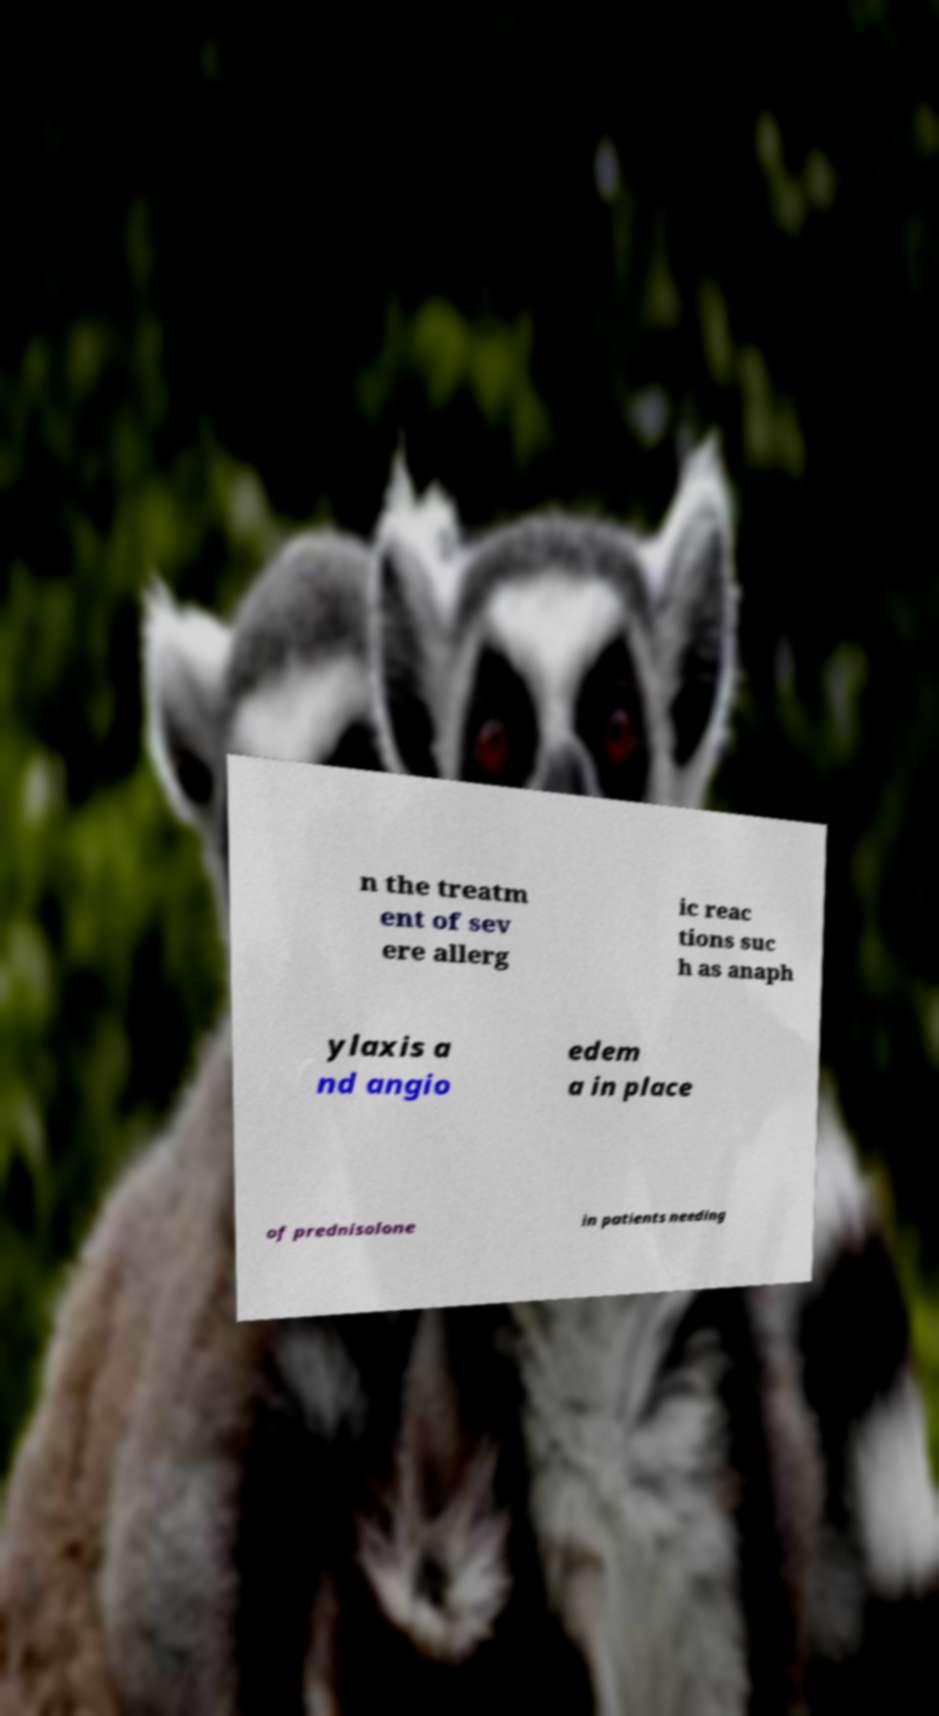Could you assist in decoding the text presented in this image and type it out clearly? n the treatm ent of sev ere allerg ic reac tions suc h as anaph ylaxis a nd angio edem a in place of prednisolone in patients needing 